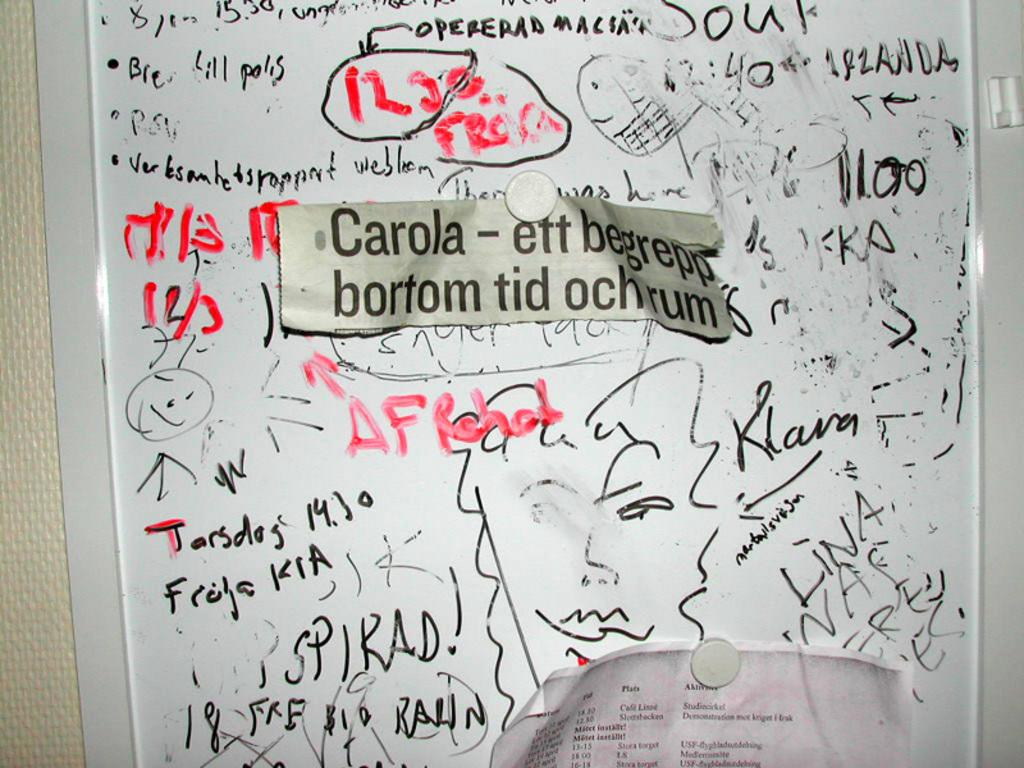<image>
Create a compact narrative representing the image presented. The newspaper cutout on the board mentions the name Carola. 